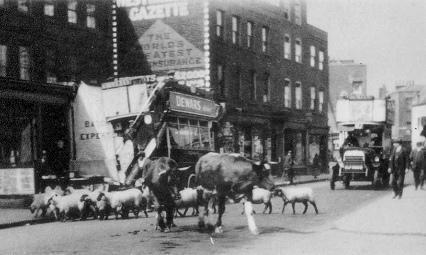How many cows can you see?
Give a very brief answer. 2. How many umbrellas are there?
Give a very brief answer. 0. 